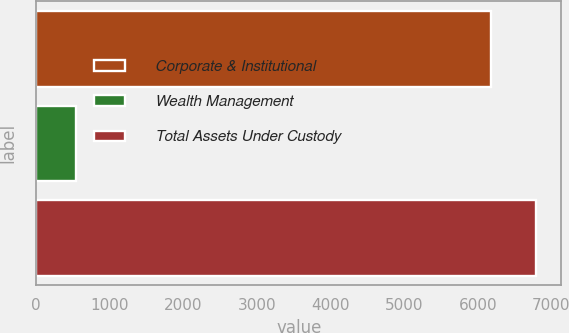Convert chart. <chart><loc_0><loc_0><loc_500><loc_500><bar_chart><fcel>Corporate & Institutional<fcel>Wealth Management<fcel>Total Assets Under Custody<nl><fcel>6176.9<fcel>543.6<fcel>6794.59<nl></chart> 